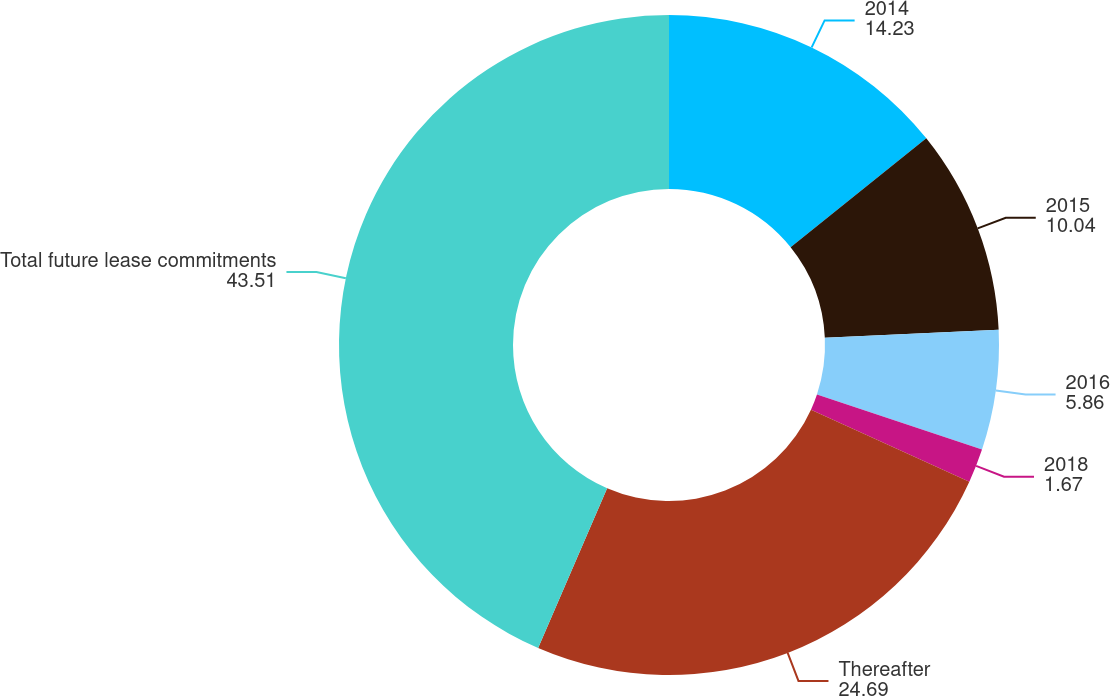<chart> <loc_0><loc_0><loc_500><loc_500><pie_chart><fcel>2014<fcel>2015<fcel>2016<fcel>2018<fcel>Thereafter<fcel>Total future lease commitments<nl><fcel>14.23%<fcel>10.04%<fcel>5.86%<fcel>1.67%<fcel>24.69%<fcel>43.51%<nl></chart> 